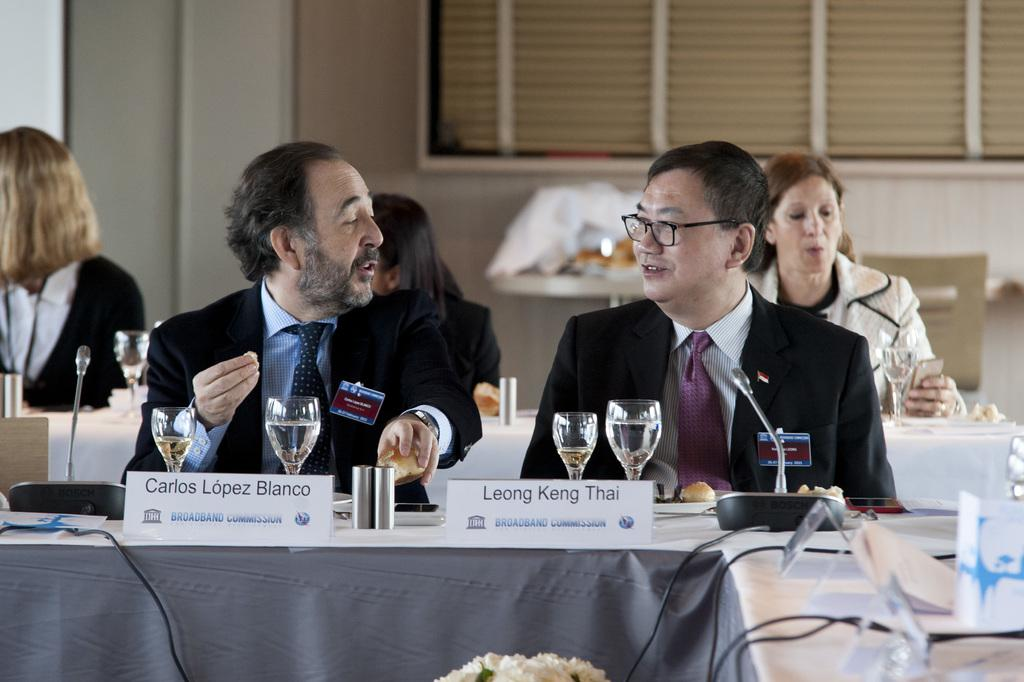What are the people in the image doing? There is a group of people sitting in the image. What objects can be seen on the table in the image? There are two glasses and a board visible on the table in the image. What can be seen in the background of the image? There is a window visible in the background of the image. What type of swing can be seen in the image? There is no swing present in the image. What is being served for lunch in the image? The image does not show any food or lunch being served. 